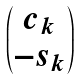Convert formula to latex. <formula><loc_0><loc_0><loc_500><loc_500>\begin{pmatrix} c _ { k } \\ - s _ { k } \end{pmatrix}</formula> 